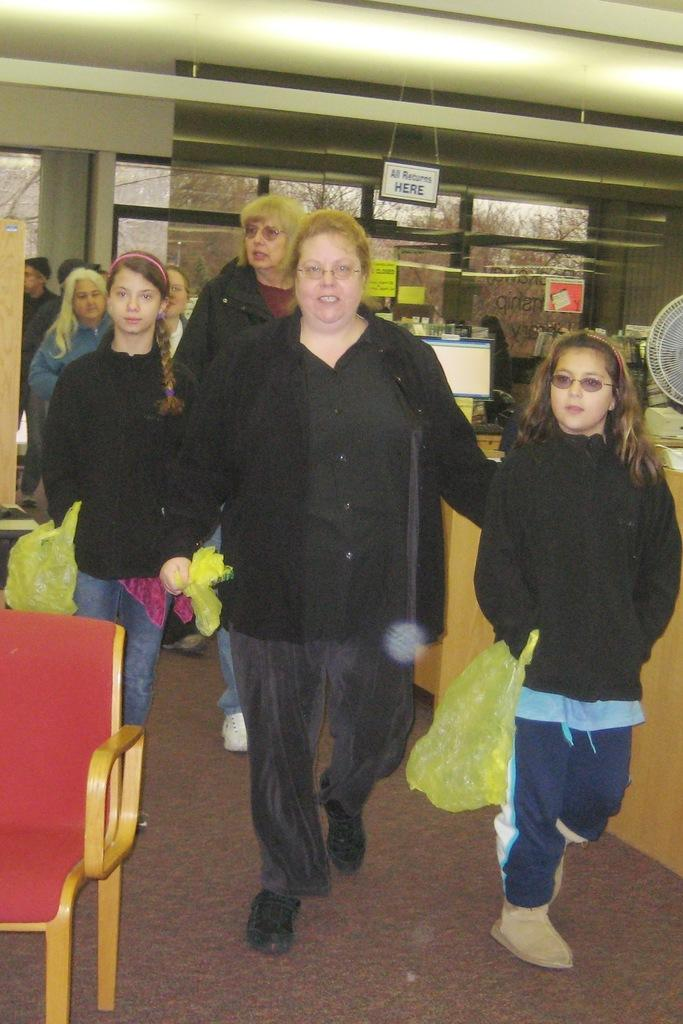Who is present in the image? There are women in the image. What are the women doing in the image? The women are walking. What are the women holding in the image? The women are holding yellow color plastic bags. Can you describe any furniture or objects in the image? There is a red color chair in the image. What type of camera can be seen in the image? There is no camera present in the image. How many trucks are visible in the image? There are no trucks visible in the image. 